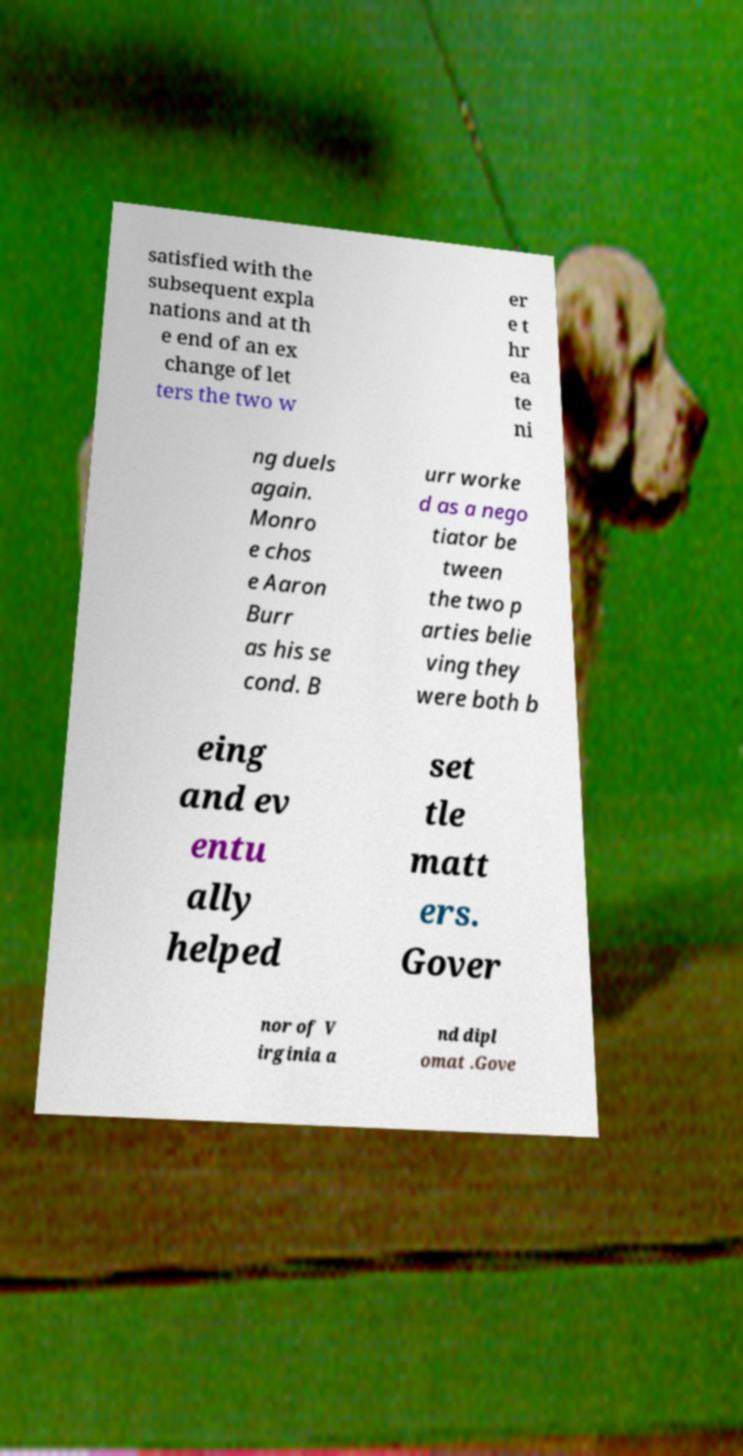There's text embedded in this image that I need extracted. Can you transcribe it verbatim? satisfied with the subsequent expla nations and at th e end of an ex change of let ters the two w er e t hr ea te ni ng duels again. Monro e chos e Aaron Burr as his se cond. B urr worke d as a nego tiator be tween the two p arties belie ving they were both b eing and ev entu ally helped set tle matt ers. Gover nor of V irginia a nd dipl omat .Gove 